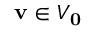<formula> <loc_0><loc_0><loc_500><loc_500>v \in V _ { 0 }</formula> 